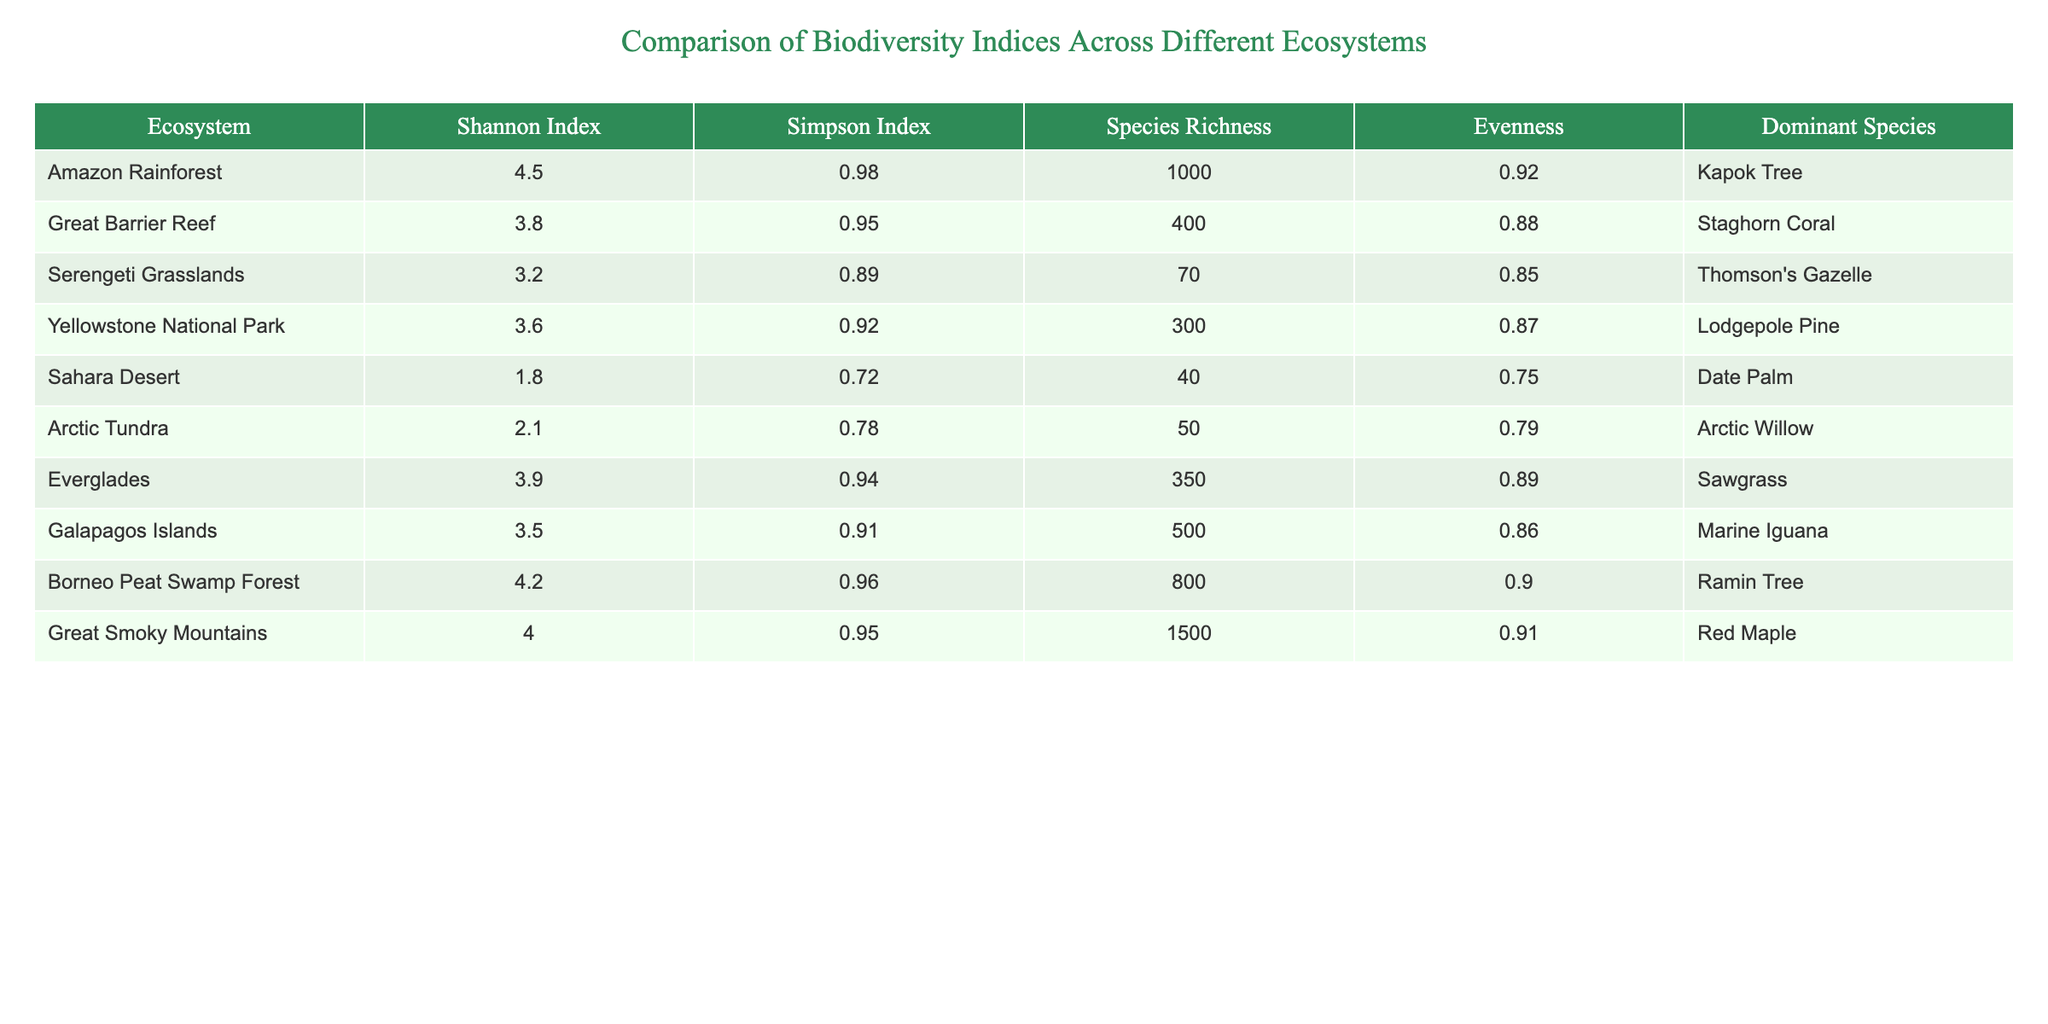What is the Shannon Index for the Amazon Rainforest? The table provides data for the Amazon Rainforest, showing a Shannon Index of 4.5.
Answer: 4.5 Which ecosystem has the lowest species richness? By comparing the Species Richness values in the table, the Sahara Desert has the lowest at 40.
Answer: Sahara Desert What is the difference in the Shannon Index between the Great Barrier Reef and the Serengeti Grasslands? The Shannon Index for the Great Barrier Reef is 3.8 and for the Serengeti Grasslands, it is 3.2. The difference is 3.8 - 3.2 = 0.6.
Answer: 0.6 Is the Evenness in the Arctic Tundra greater than 0.8? The Evenness value for Arctic Tundra is 0.79, which is less than 0.8, so the statement is false.
Answer: No What is the average Simpson Index across all ecosystems listed in the table? The Simpson Index values are 0.98, 0.95, 0.89, 0.92, 0.72, 0.78, 0.94, 0.91, 0.96, and 0.95. Summing these gives 9.06. There are 10 ecosystems, thus the average is 9.06 / 10 = 0.906.
Answer: 0.906 Which ecosystem has the highest Evenness and what is its value? The table shows that the Great Smoky Mountains have the highest Evenness at 0.91.
Answer: Great Smoky Mountains, 0.91 How many ecosystems have a Simpson Index greater than 0.9? The following ecosystems have a Simpson Index greater than 0.9: Amazon Rainforest, Great Barrier Reef, Borneo Peat Swamp Forest, Great Smoky Mountains, and Everglades. This totals 5 ecosystems.
Answer: 5 Calculate the total Species Richness for all ecosystems combined. To find the total Species Richness, we sum the values: 1000 + 400 + 70 + 300 + 40 + 50 + 350 + 500 + 800 + 1500 = 4160.
Answer: 4160 Is the Dominant Species in the Sahara Desert a tree? The Dominant Species in the Sahara Desert is the Date Palm, which is a type of tree, so the statement is true.
Answer: Yes What is the relationship between the Shannon Index and Evenness for the Borneo Peat Swamp Forest? The Shannon Index for the Borneo Peat Swamp Forest is 4.2 and its Evenness is 0.90. This indicates high biodiversity along with good species evenness.
Answer: High biodiversity and good evenness 